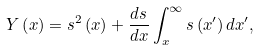Convert formula to latex. <formula><loc_0><loc_0><loc_500><loc_500>Y \left ( x \right ) = s ^ { 2 } \left ( x \right ) + \frac { d s } { d x } \int _ { x } ^ { \infty } s \left ( x ^ { \prime } \right ) d x ^ { \prime } ,</formula> 